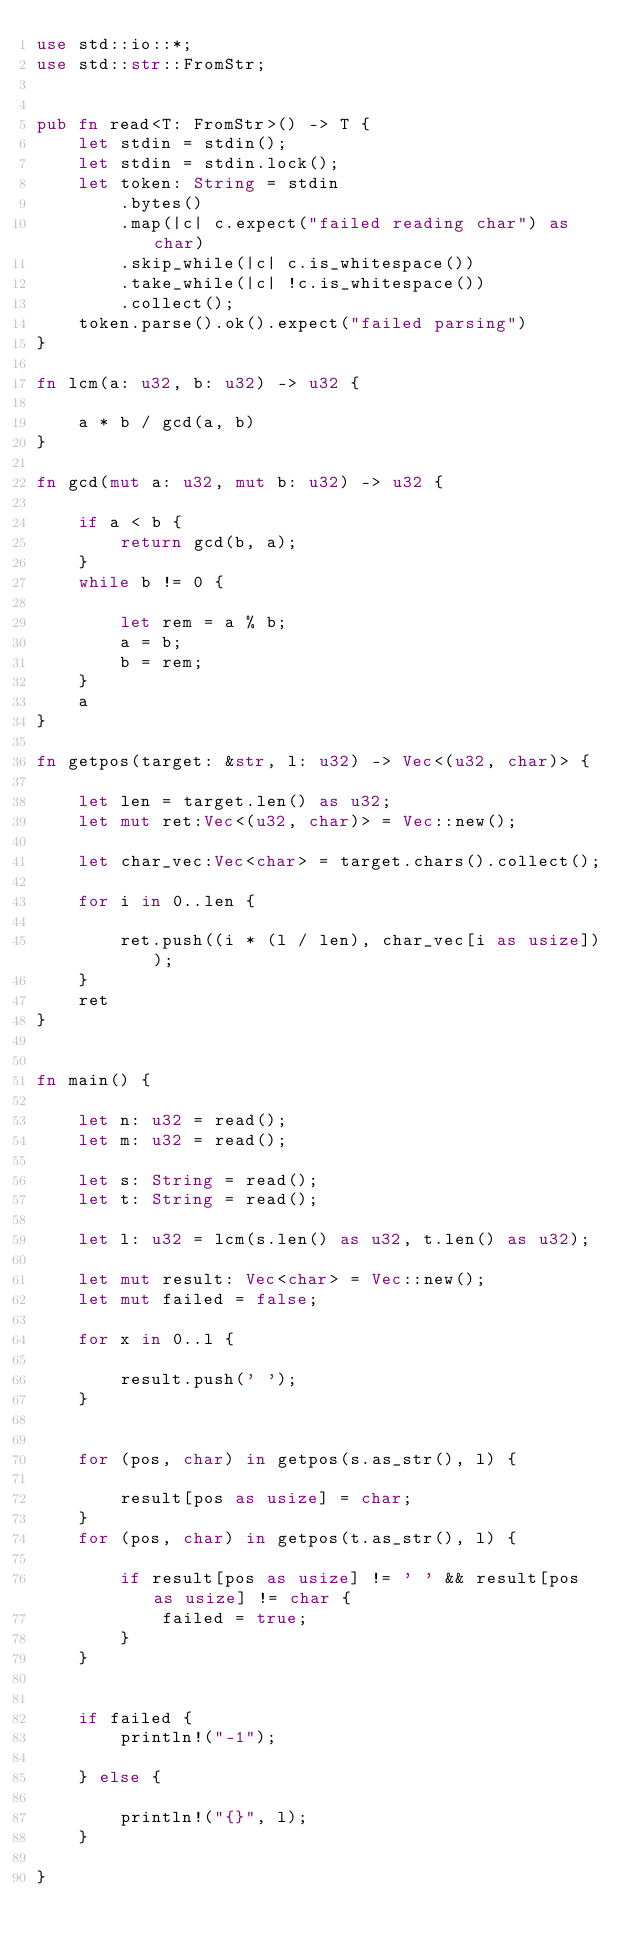<code> <loc_0><loc_0><loc_500><loc_500><_Rust_>use std::io::*;
use std::str::FromStr;


pub fn read<T: FromStr>() -> T {
    let stdin = stdin();
    let stdin = stdin.lock();
    let token: String = stdin
        .bytes()
        .map(|c| c.expect("failed reading char") as char)
        .skip_while(|c| c.is_whitespace())
        .take_while(|c| !c.is_whitespace())
        .collect();
    token.parse().ok().expect("failed parsing")
}

fn lcm(a: u32, b: u32) -> u32 {

    a * b / gcd(a, b)
}

fn gcd(mut a: u32, mut b: u32) -> u32 {

    if a < b {
        return gcd(b, a);
    }
    while b != 0 {

        let rem = a % b;
        a = b;
        b = rem;
    }
    a
}

fn getpos(target: &str, l: u32) -> Vec<(u32, char)> {

    let len = target.len() as u32;
    let mut ret:Vec<(u32, char)> = Vec::new();

    let char_vec:Vec<char> = target.chars().collect();

    for i in 0..len {

        ret.push((i * (l / len), char_vec[i as usize]));
    }
    ret
}


fn main() {

    let n: u32 = read();
    let m: u32 = read();

    let s: String = read();
    let t: String = read();

    let l: u32 = lcm(s.len() as u32, t.len() as u32);

    let mut result: Vec<char> = Vec::new();
    let mut failed = false;

    for x in 0..l {

        result.push(' ');
    }


    for (pos, char) in getpos(s.as_str(), l) {

        result[pos as usize] = char;
    }
    for (pos, char) in getpos(t.as_str(), l) {

        if result[pos as usize] != ' ' && result[pos as usize] != char {
            failed = true;
        }
    }


    if failed {
        println!("-1");

    } else {

        println!("{}", l);
    }

}
</code> 